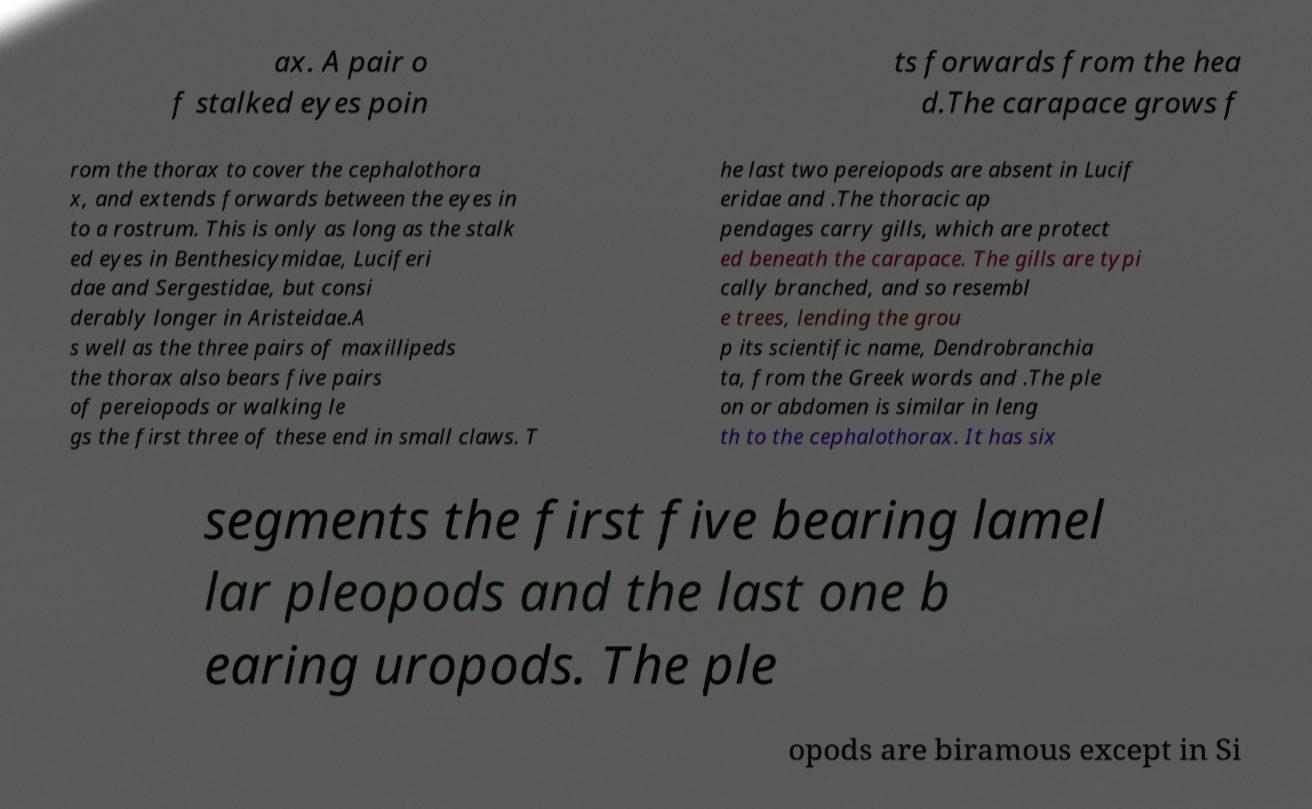Please read and relay the text visible in this image. What does it say? ax. A pair o f stalked eyes poin ts forwards from the hea d.The carapace grows f rom the thorax to cover the cephalothora x, and extends forwards between the eyes in to a rostrum. This is only as long as the stalk ed eyes in Benthesicymidae, Luciferi dae and Sergestidae, but consi derably longer in Aristeidae.A s well as the three pairs of maxillipeds the thorax also bears five pairs of pereiopods or walking le gs the first three of these end in small claws. T he last two pereiopods are absent in Lucif eridae and .The thoracic ap pendages carry gills, which are protect ed beneath the carapace. The gills are typi cally branched, and so resembl e trees, lending the grou p its scientific name, Dendrobranchia ta, from the Greek words and .The ple on or abdomen is similar in leng th to the cephalothorax. It has six segments the first five bearing lamel lar pleopods and the last one b earing uropods. The ple opods are biramous except in Si 